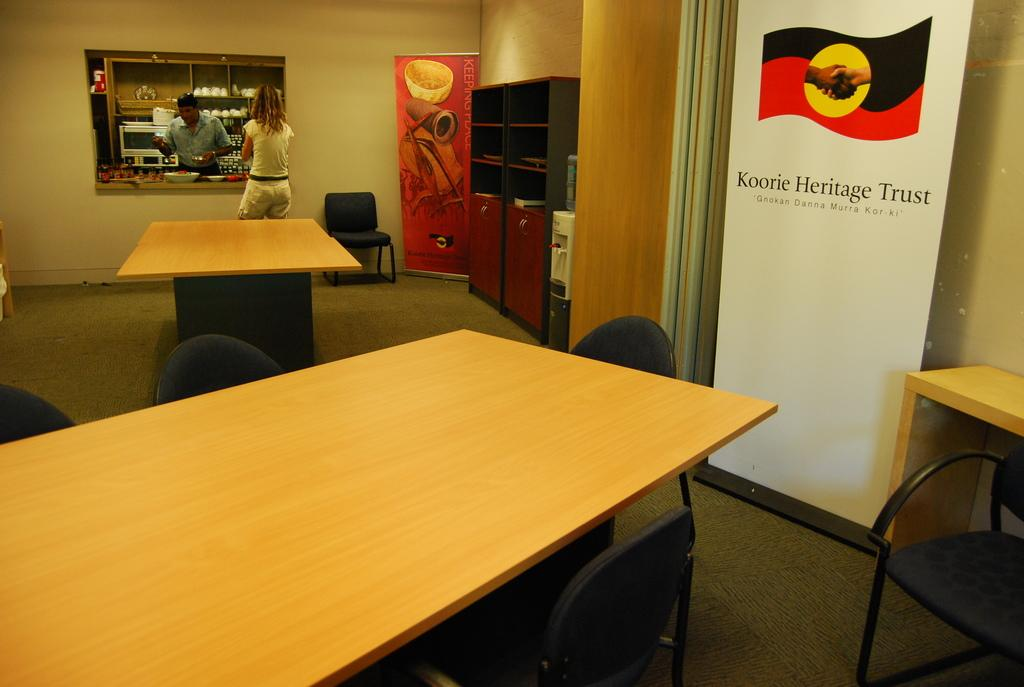What type of furniture is present in the image? There is a table and chairs in the image. What type of signage can be seen in the image? There are hoardings in the image. What type of appliance is present in the image? There is a water filter in the image. What type of storage is present in the image? There are cupboards in the image. How many people are in the image? There are two persons in the image. What type of cooking appliance is visible behind one of the persons? There is an oven behind one of the persons. What type of dishware is visible behind one of the persons? There are cups behind one of the persons. What type of knot is tied on the water filter in the image? There is no knot present on the water filter in the image. What type of line is visible connecting the two persons in the image? There is no line connecting the two persons in the image. 